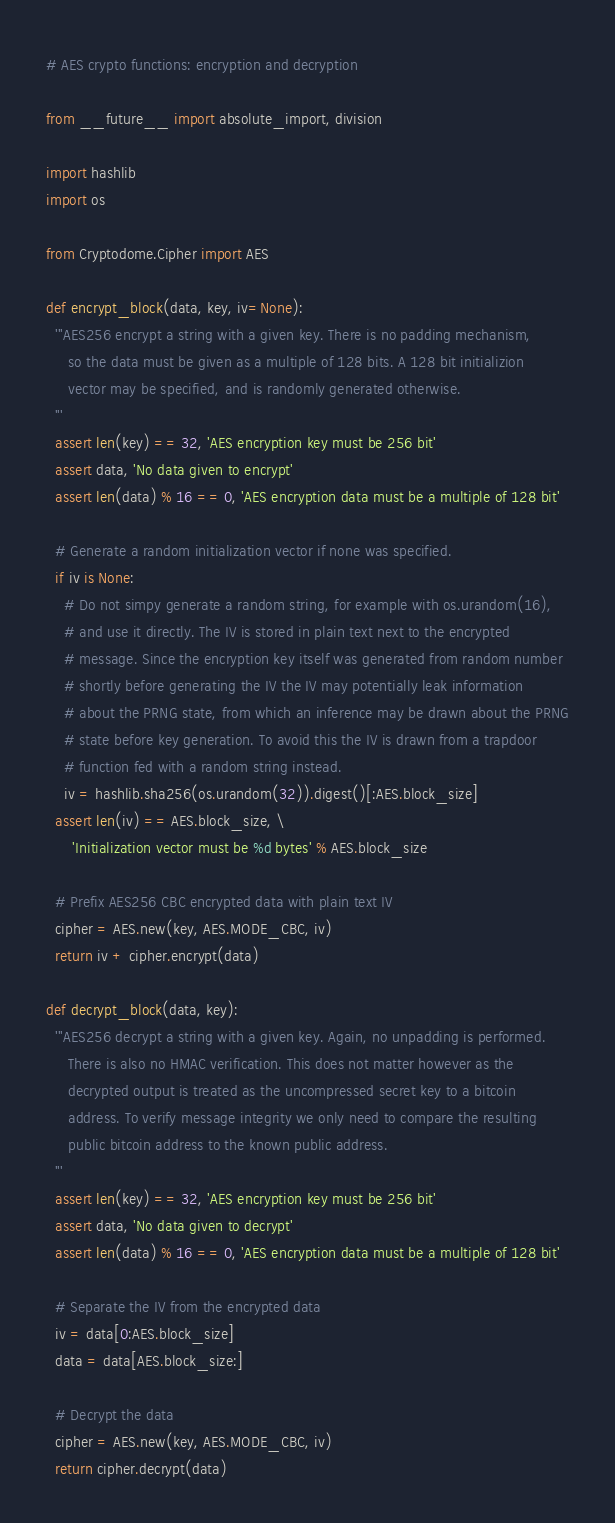<code> <loc_0><loc_0><loc_500><loc_500><_Python_># AES crypto functions: encryption and decryption

from __future__ import absolute_import, division

import hashlib
import os

from Cryptodome.Cipher import AES

def encrypt_block(data, key, iv=None):
  '''AES256 encrypt a string with a given key. There is no padding mechanism,
     so the data must be given as a multiple of 128 bits. A 128 bit initializion
     vector may be specified, and is randomly generated otherwise.
  '''
  assert len(key) == 32, 'AES encryption key must be 256 bit'
  assert data, 'No data given to encrypt'
  assert len(data) % 16 == 0, 'AES encryption data must be a multiple of 128 bit'

  # Generate a random initialization vector if none was specified.
  if iv is None:
    # Do not simpy generate a random string, for example with os.urandom(16),
    # and use it directly. The IV is stored in plain text next to the encrypted
    # message. Since the encryption key itself was generated from random number
    # shortly before generating the IV the IV may potentially leak information
    # about the PRNG state, from which an inference may be drawn about the PRNG
    # state before key generation. To avoid this the IV is drawn from a trapdoor
    # function fed with a random string instead.
    iv = hashlib.sha256(os.urandom(32)).digest()[:AES.block_size]
  assert len(iv) == AES.block_size, \
      'Initialization vector must be %d bytes' % AES.block_size

  # Prefix AES256 CBC encrypted data with plain text IV
  cipher = AES.new(key, AES.MODE_CBC, iv)
  return iv + cipher.encrypt(data)

def decrypt_block(data, key):
  '''AES256 decrypt a string with a given key. Again, no unpadding is performed.
     There is also no HMAC verification. This does not matter however as the
     decrypted output is treated as the uncompressed secret key to a bitcoin
     address. To verify message integrity we only need to compare the resulting
     public bitcoin address to the known public address.
  '''
  assert len(key) == 32, 'AES encryption key must be 256 bit'
  assert data, 'No data given to decrypt'
  assert len(data) % 16 == 0, 'AES encryption data must be a multiple of 128 bit'

  # Separate the IV from the encrypted data
  iv = data[0:AES.block_size]
  data = data[AES.block_size:]

  # Decrypt the data
  cipher = AES.new(key, AES.MODE_CBC, iv)
  return cipher.decrypt(data)
</code> 